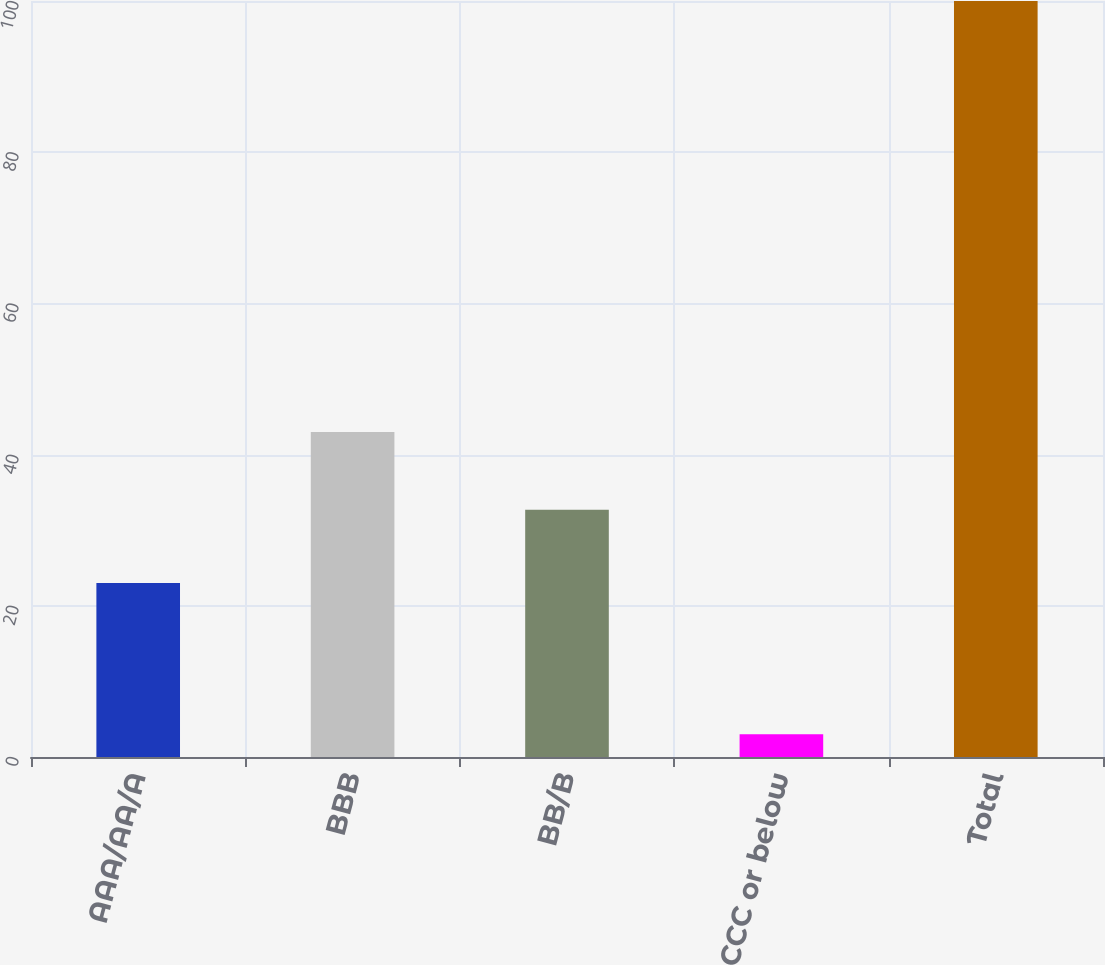<chart> <loc_0><loc_0><loc_500><loc_500><bar_chart><fcel>AAA/AA/A<fcel>BBB<fcel>BB/B<fcel>CCC or below<fcel>Total<nl><fcel>23<fcel>43<fcel>32.7<fcel>3<fcel>100<nl></chart> 